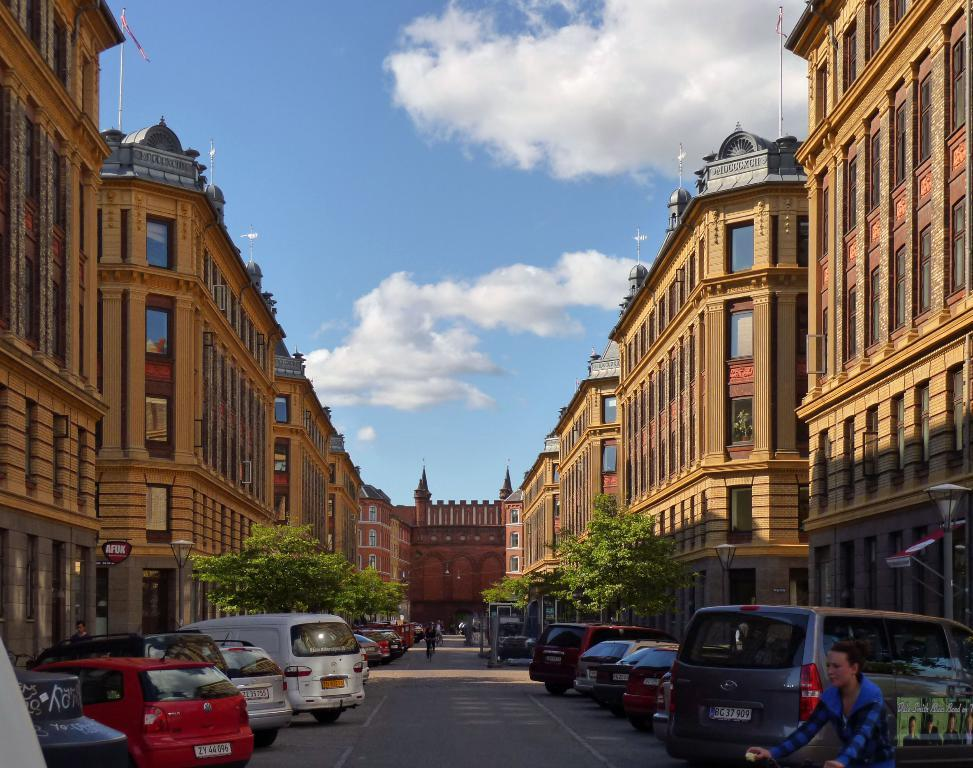What type of vehicles can be seen in the image? There are cars in the image. What is the primary feature of the image? There is a road in the image. Can you identify any living beings in the image? Yes, there are people visible in the image. What can be seen in the distance in the image? There are buildings and trees in the background of the image, and the sky is clear. What type of songs can be heard being sung by the kitty in the image? There is no kitty present in the image, and therefore no songs can be heard. 